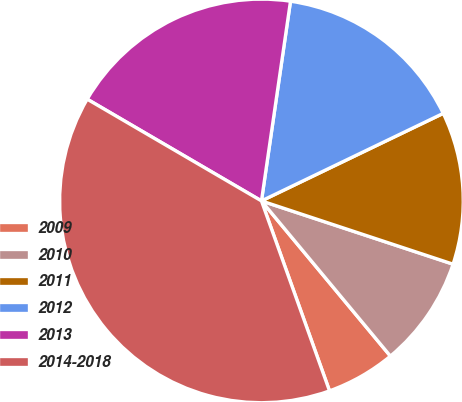Convert chart. <chart><loc_0><loc_0><loc_500><loc_500><pie_chart><fcel>2009<fcel>2010<fcel>2011<fcel>2012<fcel>2013<fcel>2014-2018<nl><fcel>5.56%<fcel>8.89%<fcel>12.22%<fcel>15.56%<fcel>18.89%<fcel>38.89%<nl></chart> 